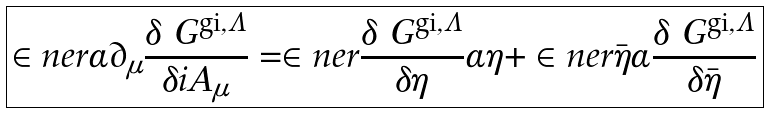Convert formula to latex. <formula><loc_0><loc_0><loc_500><loc_500>\boxed { \in n e r { \alpha } { \partial _ { \mu } \frac { \delta \ G ^ { \text {gi} , \Lambda } } { \delta i A _ { \mu } } } = \in n e r { \frac { \delta \ G ^ { \text {gi} , \Lambda } } { \delta \eta } } { \alpha \eta } + \in n e r { \bar { \eta } } { \alpha \frac { \delta \ G ^ { \text {gi} , \Lambda } } { \delta \bar { \eta } } } }</formula> 